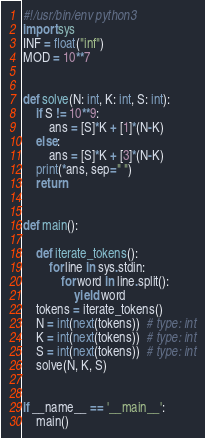Convert code to text. <code><loc_0><loc_0><loc_500><loc_500><_Python_>#!/usr/bin/env python3
import sys
INF = float("inf")
MOD = 10**7


def solve(N: int, K: int, S: int):
    if S != 10**9:
        ans = [S]*K + [1]*(N-K)
    else:
        ans = [S]*K + [3]*(N-K)
    print(*ans, sep=" ")
    return


def main():

    def iterate_tokens():
        for line in sys.stdin:
            for word in line.split():
                yield word
    tokens = iterate_tokens()
    N = int(next(tokens))  # type: int
    K = int(next(tokens))  # type: int
    S = int(next(tokens))  # type: int
    solve(N, K, S)


if __name__ == '__main__':
    main()
</code> 